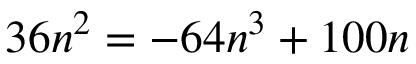Convert formula to latex. <formula><loc_0><loc_0><loc_500><loc_500>3 6 n ^ { 2 } = - 6 4 n ^ { 3 } + 1 0 0 n</formula> 